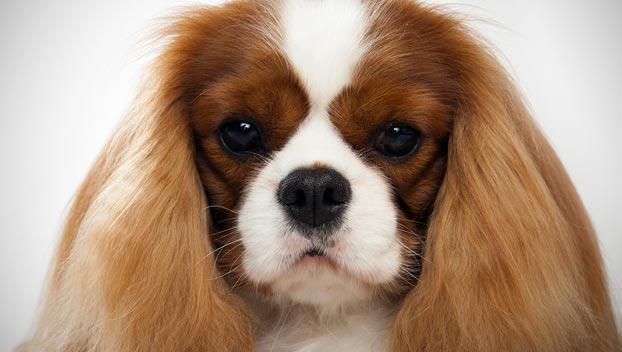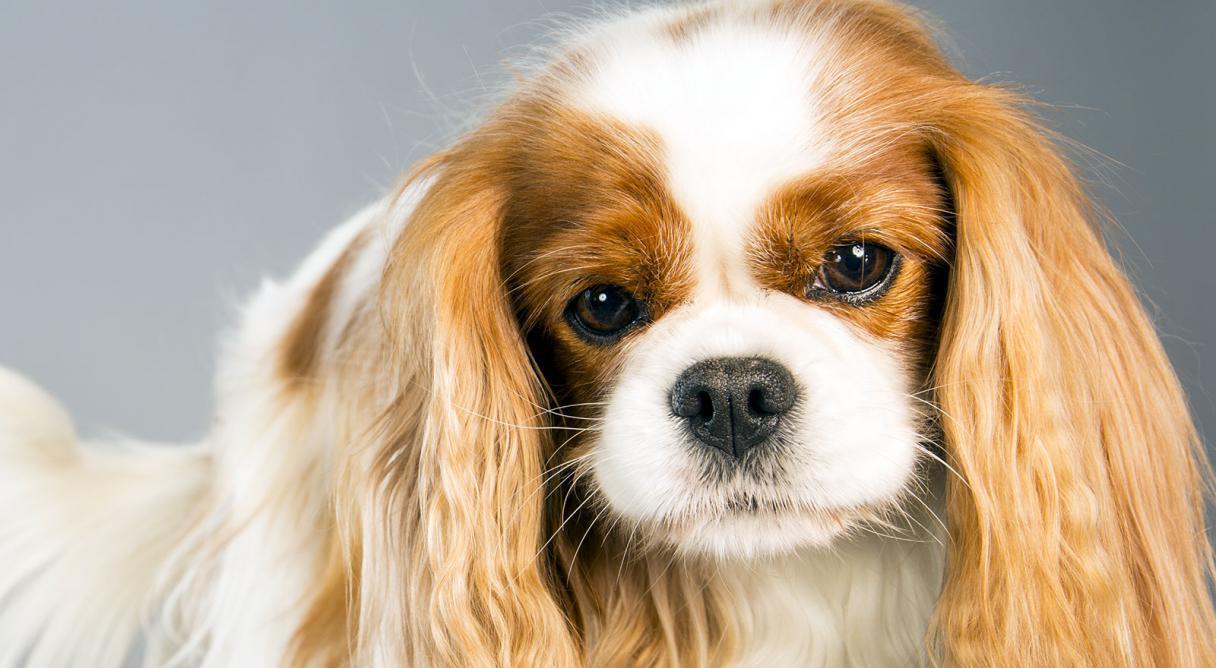The first image is the image on the left, the second image is the image on the right. For the images shown, is this caption "At least one animal is on the grass." true? Answer yes or no. No. 